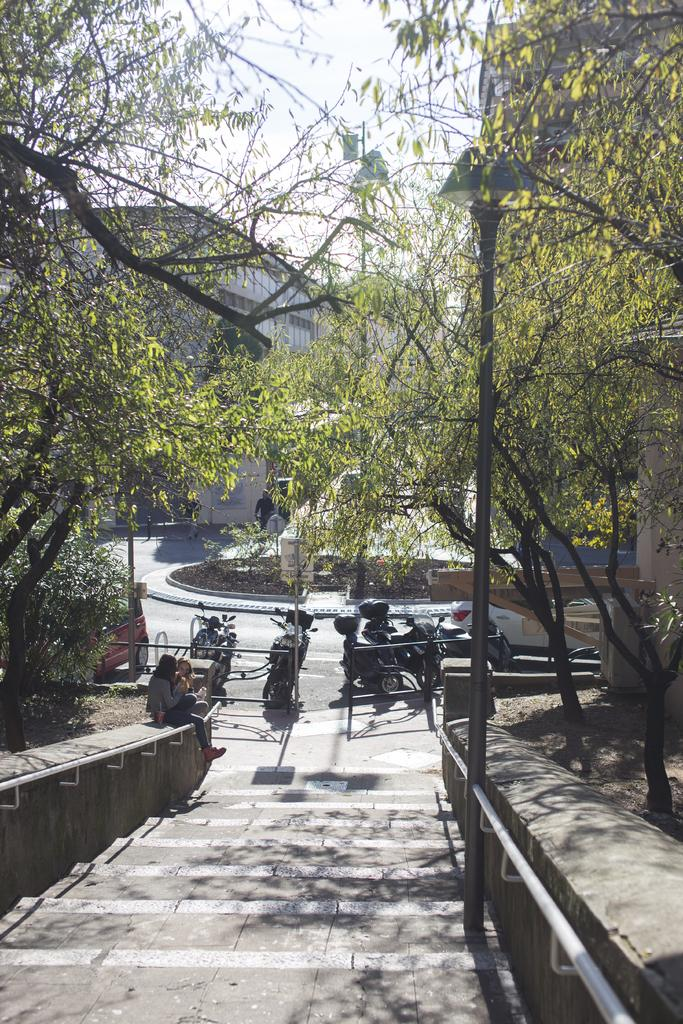What can be seen at the bottom of the image? There are stairs at the bottom of the image. What are people doing on the stairs? People are sitting on the stairs. What is on the right side of the image? There is a pole on the right side of the image. What can be seen in the background of the image? Trees, bikes, a car, a building, and a person are visible in the background of the image. What is the color of the sky in the image? The sky is visible in the background of the image, but the color is not mentioned in the facts. How many cows are present in the image? There are no cows present in the image. What type of ring can be seen on the person's finger in the image? There is no person wearing a ring in the image. 